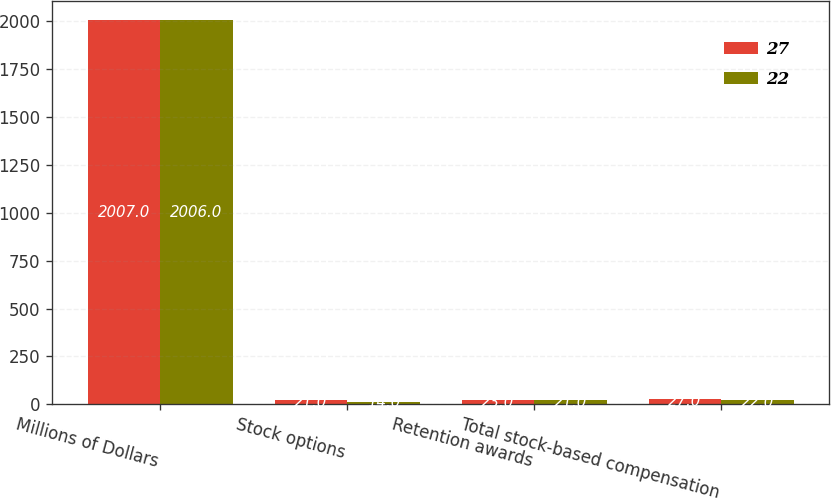<chart> <loc_0><loc_0><loc_500><loc_500><stacked_bar_chart><ecel><fcel>Millions of Dollars<fcel>Stock options<fcel>Retention awards<fcel>Total stock-based compensation<nl><fcel>27<fcel>2007<fcel>21<fcel>23<fcel>27<nl><fcel>22<fcel>2006<fcel>14<fcel>21<fcel>22<nl></chart> 